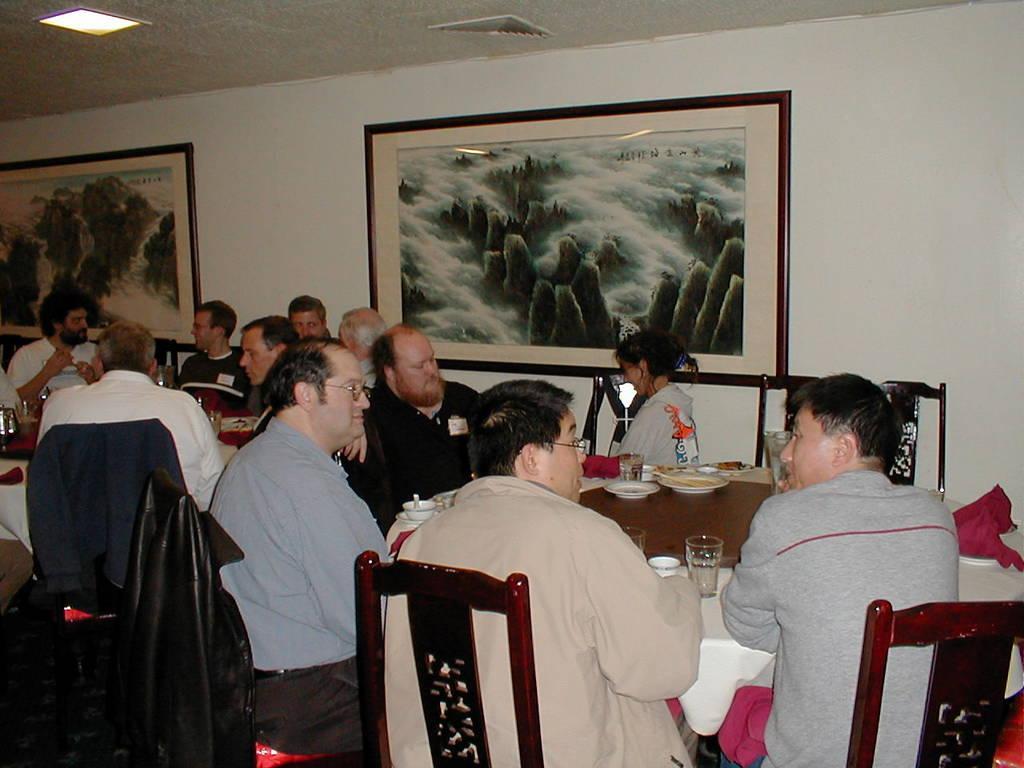Could you give a brief overview of what you see in this image? In this image there are group of people sitting on the chair. On the table there is glass,cup,plate,spoon. On the wall there is a frame. 